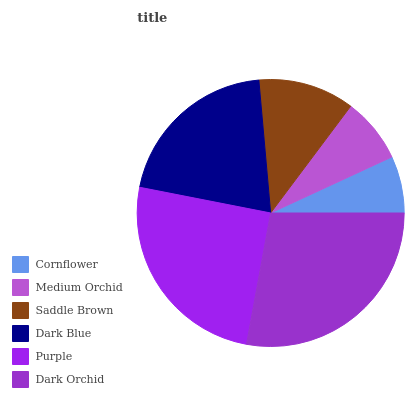Is Cornflower the minimum?
Answer yes or no. Yes. Is Dark Orchid the maximum?
Answer yes or no. Yes. Is Medium Orchid the minimum?
Answer yes or no. No. Is Medium Orchid the maximum?
Answer yes or no. No. Is Medium Orchid greater than Cornflower?
Answer yes or no. Yes. Is Cornflower less than Medium Orchid?
Answer yes or no. Yes. Is Cornflower greater than Medium Orchid?
Answer yes or no. No. Is Medium Orchid less than Cornflower?
Answer yes or no. No. Is Dark Blue the high median?
Answer yes or no. Yes. Is Saddle Brown the low median?
Answer yes or no. Yes. Is Dark Orchid the high median?
Answer yes or no. No. Is Medium Orchid the low median?
Answer yes or no. No. 